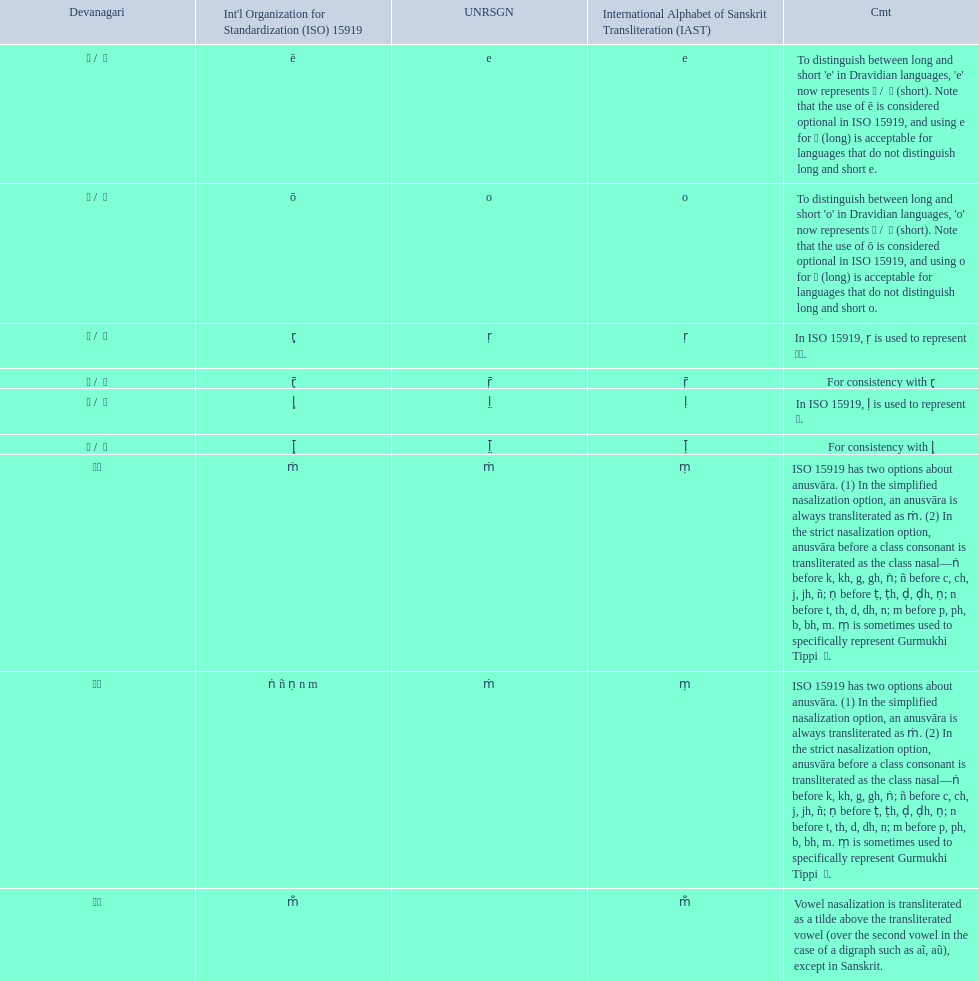How many total options are there about anusvara? 2. 